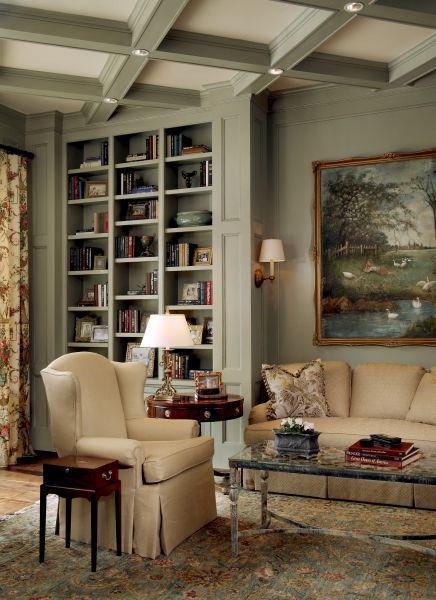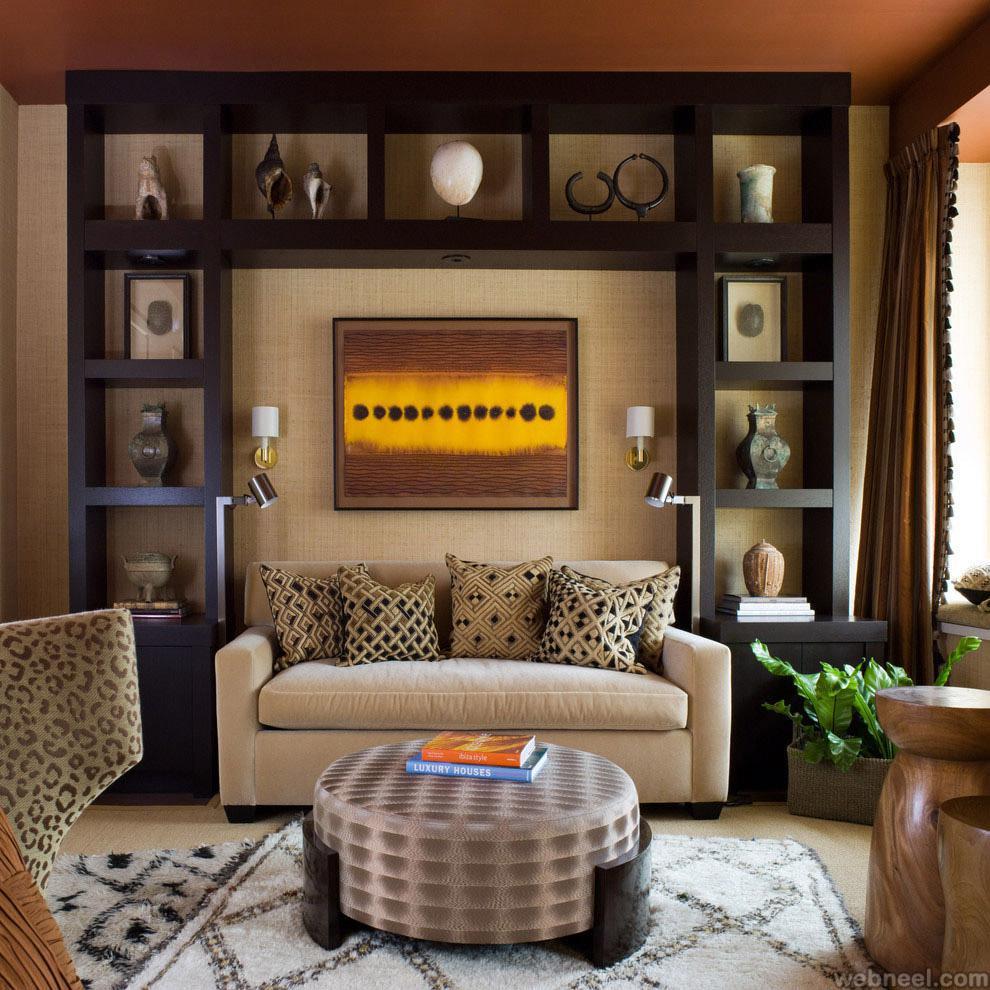The first image is the image on the left, the second image is the image on the right. Examine the images to the left and right. Is the description "In at least one image there is a green wall with at least two framed pictures." accurate? Answer yes or no. No. The first image is the image on the left, the second image is the image on the right. Considering the images on both sides, is "The left image shows framed pictures on the front of green bookshelves in front of a green wall, and a brown sofa in front of the bookshelves." valid? Answer yes or no. No. 